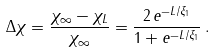<formula> <loc_0><loc_0><loc_500><loc_500>\Delta \chi = \frac { \chi _ { \infty } - \chi _ { L } } { \chi _ { \infty } } = \frac { 2 \, e ^ { - L / \xi _ { 1 } } } { 1 + e ^ { - L / \xi _ { 1 } } } \, .</formula> 